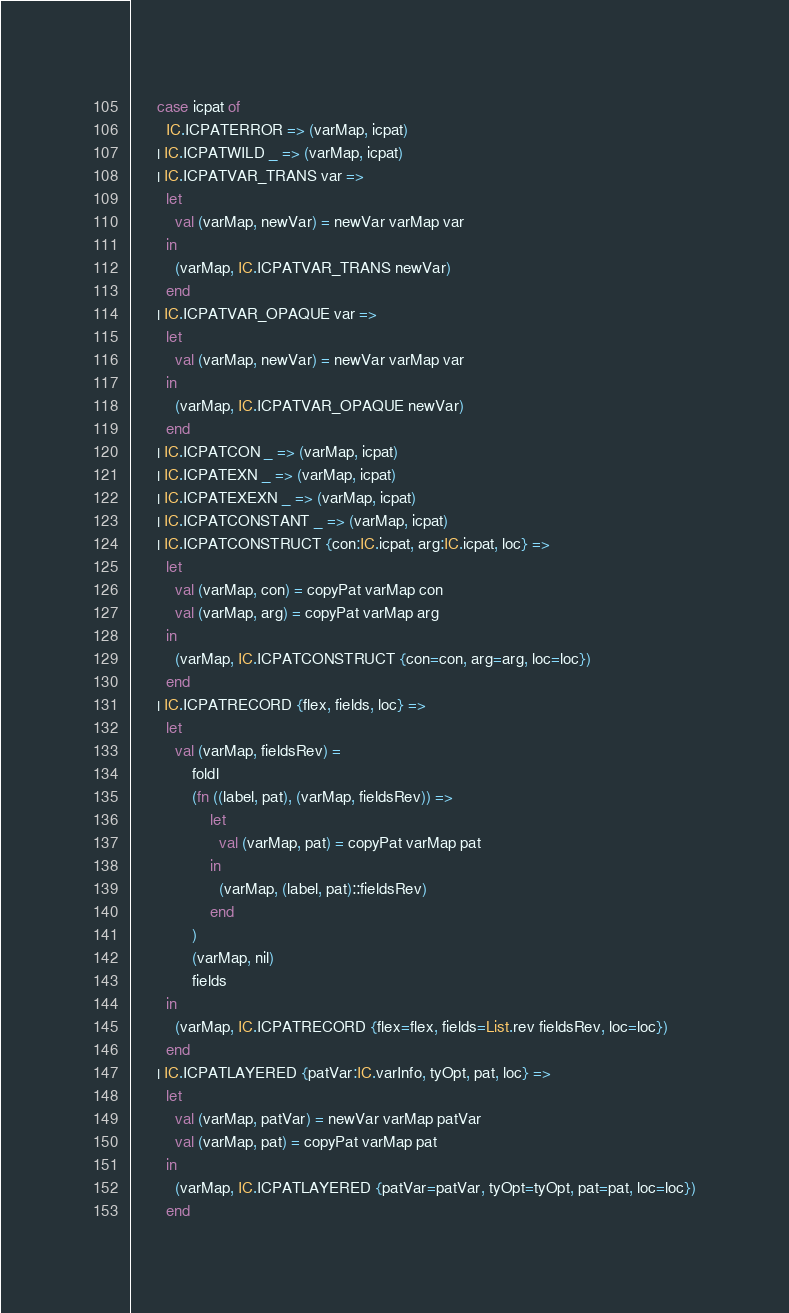Convert code to text. <code><loc_0><loc_0><loc_500><loc_500><_SML_>      case icpat of
        IC.ICPATERROR => (varMap, icpat)
      | IC.ICPATWILD _ => (varMap, icpat)
      | IC.ICPATVAR_TRANS var =>
        let
          val (varMap, newVar) = newVar varMap var
        in
          (varMap, IC.ICPATVAR_TRANS newVar)
        end
      | IC.ICPATVAR_OPAQUE var =>
        let
          val (varMap, newVar) = newVar varMap var
        in
          (varMap, IC.ICPATVAR_OPAQUE newVar)
        end
      | IC.ICPATCON _ => (varMap, icpat)
      | IC.ICPATEXN _ => (varMap, icpat)
      | IC.ICPATEXEXN _ => (varMap, icpat)
      | IC.ICPATCONSTANT _ => (varMap, icpat)
      | IC.ICPATCONSTRUCT {con:IC.icpat, arg:IC.icpat, loc} =>
        let
          val (varMap, con) = copyPat varMap con
          val (varMap, arg) = copyPat varMap arg
        in
          (varMap, IC.ICPATCONSTRUCT {con=con, arg=arg, loc=loc})
        end
      | IC.ICPATRECORD {flex, fields, loc} =>
        let
          val (varMap, fieldsRev) =
              foldl
              (fn ((label, pat), (varMap, fieldsRev)) =>
                  let
                    val (varMap, pat) = copyPat varMap pat
                  in
                    (varMap, (label, pat)::fieldsRev)
                  end
              )
              (varMap, nil)
              fields
        in
          (varMap, IC.ICPATRECORD {flex=flex, fields=List.rev fieldsRev, loc=loc})
        end
      | IC.ICPATLAYERED {patVar:IC.varInfo, tyOpt, pat, loc} =>
        let
          val (varMap, patVar) = newVar varMap patVar
          val (varMap, pat) = copyPat varMap pat
        in
          (varMap, IC.ICPATLAYERED {patVar=patVar, tyOpt=tyOpt, pat=pat, loc=loc})
        end</code> 